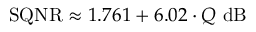<formula> <loc_0><loc_0><loc_500><loc_500>S Q N R \approx 1 . 7 6 1 + 6 . 0 2 \cdot Q \ d B \,</formula> 